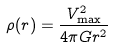Convert formula to latex. <formula><loc_0><loc_0><loc_500><loc_500>\rho ( r ) = \frac { V ^ { 2 } _ { \max } } { 4 \pi G r ^ { 2 } }</formula> 